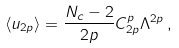Convert formula to latex. <formula><loc_0><loc_0><loc_500><loc_500>\langle u _ { 2 p } \rangle = \frac { N _ { c } - 2 } { 2 p } C ^ { p } _ { 2 p } \Lambda ^ { 2 p } \, ,</formula> 